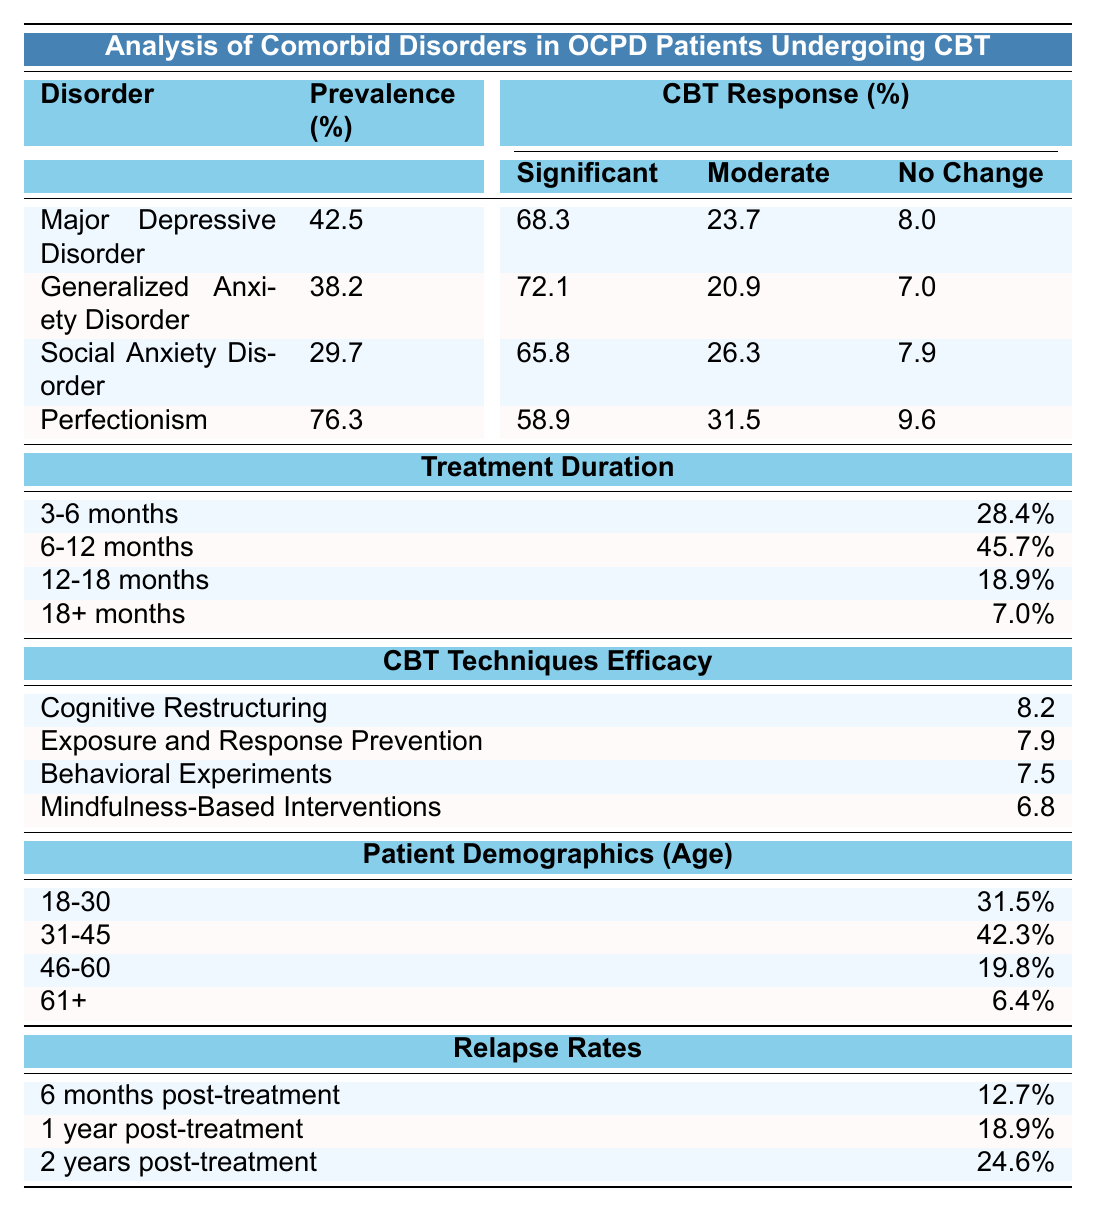What is the prevalence percentage of Major Depressive Disorder among OCPD patients? The table shows that Major Depressive Disorder has a prevalence of 42.5% in OCPD patients.
Answer: 42.5% What percentage of patients experienced significant improvement in Generalized Anxiety Disorder after CBT? According to the table, 72.1% of patients with Generalized Anxiety Disorder experienced significant improvement after undergoing CBT.
Answer: 72.1% Which CBT technique has the highest efficacy rating? The efficacy ratings show that Cognitive Restructuring has the highest efficacy rating of 8.2 compared to other techniques listed.
Answer: 8.2 How many patients treated for Perfectionism showed no significant change? For Perfectionism, 9.6% of patients experienced no significant change after treatment, as stated in the table.
Answer: 9.6% What is the average prevalence percentage of the comorbid disorders listed? The average prevalence can be calculated as (42.5 + 38.2 + 29.7 + 76.3)/4 = 46.175, thus the average prevalence percentage is approximately 46.2%.
Answer: 46.2% Are there more patients aged 31-45 or aged 18-30 receiving CBT for OCPD? Comparing the percentages, 42.3% of patients are aged 31-45 while 31.5% are aged 18-30, so more patients are aged 31-45.
Answer: Yes What is the total percentage of patients undergoing treatment for 12 months or longer? The total percentage for 12 months or longer is calculated as 18.9% (12-18 months) + 7.0% (18+ months) = 25.9%.
Answer: 25.9% What is the difference in significant improvement rates between Generalized Anxiety Disorder and Social Anxiety Disorder? The significant improvement rate for Generalized Anxiety Disorder is 72.1% and for Social Anxiety Disorder is 65.8%. The difference is 72.1% - 65.8% = 6.3%.
Answer: 6.3% How does the relapse rate change from 6 months to 1 year post-treatment? The relapse rate increases from 12.7% at 6 months to 18.9% at 1 year, indicating a rise of 6.2%.
Answer: 6.2% What percentage of patients receiving CBT for OCPD are aged 60 or older? The table indicates that only 6.4% of patients are aged 61 and older.
Answer: 6.4% 